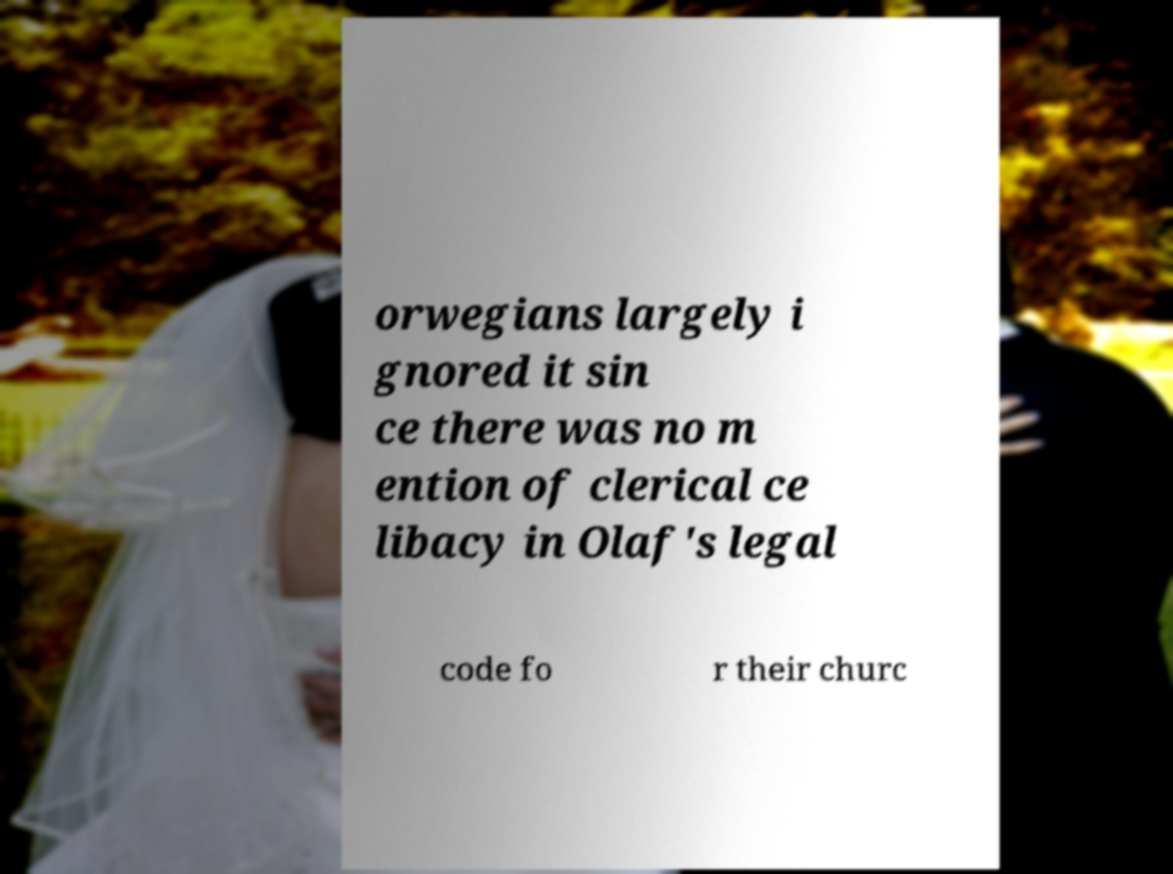Could you assist in decoding the text presented in this image and type it out clearly? orwegians largely i gnored it sin ce there was no m ention of clerical ce libacy in Olaf's legal code fo r their churc 